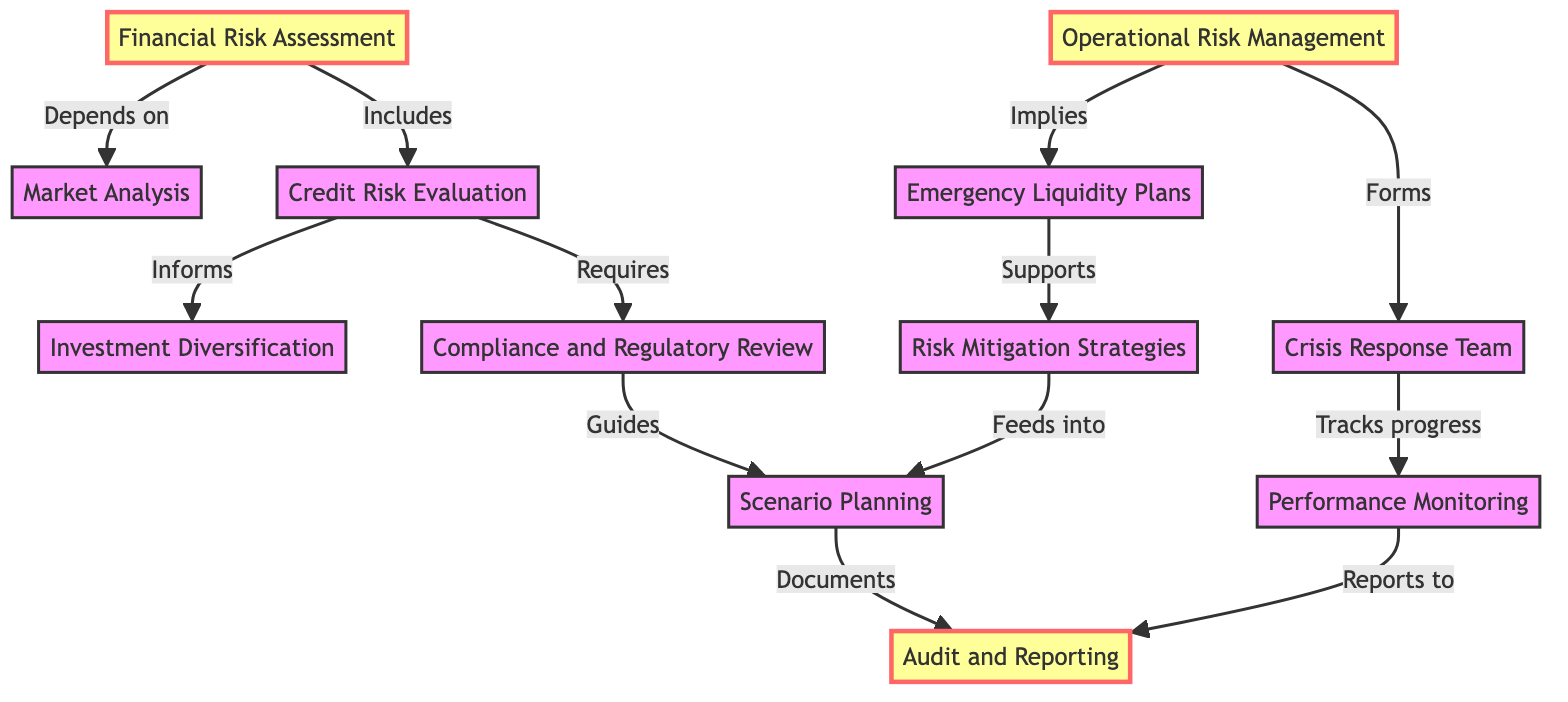What is the number of nodes in the diagram? The diagram lists 12 unique nodes in total, as enumerated in the data section.
Answer: 12 Which node does "Credit Risk Evaluation" inform? The edge from "Credit Risk Evaluation" indicates that it informs "Investment Diversification."
Answer: Investment Diversification What does "Operational Risk Management" imply? The directed edge shows that "Operational Risk Management" implies "Emergency Liquidity Plans."
Answer: Emergency Liquidity Plans How does "Compliance and Regulatory Review" relate to "Scenario Planning"? The diagram indicates that "Compliance and Regulatory Review" guides "Scenario Planning" through a directed edge.
Answer: Guides What is the final outcome of the flow after "Scenario Planning"? After following the directed edge, "Scenario Planning" documents its results to "Audit and Reporting."
Answer: Audit and Reporting How many edges are present in the diagram? In total, there are 11 edges connecting the nodes, demonstrating the relationships among them.
Answer: 11 Which node tracks the progress of the "Crisis Response Team"? The directed edge shows that "Crisis Response Team" is tracked by "Performance Monitoring."
Answer: Performance Monitoring Which nodes directly depend on "Financial Risk Assessment"? "Market Analysis" and "Credit Risk Evaluation" directly depend on "Financial Risk Assessment," as evidenced by the two outgoing edges.
Answer: Market Analysis, Credit Risk Evaluation What is the relationship between "Emergency Liquidity Plans" and "Risk Mitigation Strategies"? The directed edge indicates that "Emergency Liquidity Plans" supports "Risk Mitigation Strategies."
Answer: Supports 